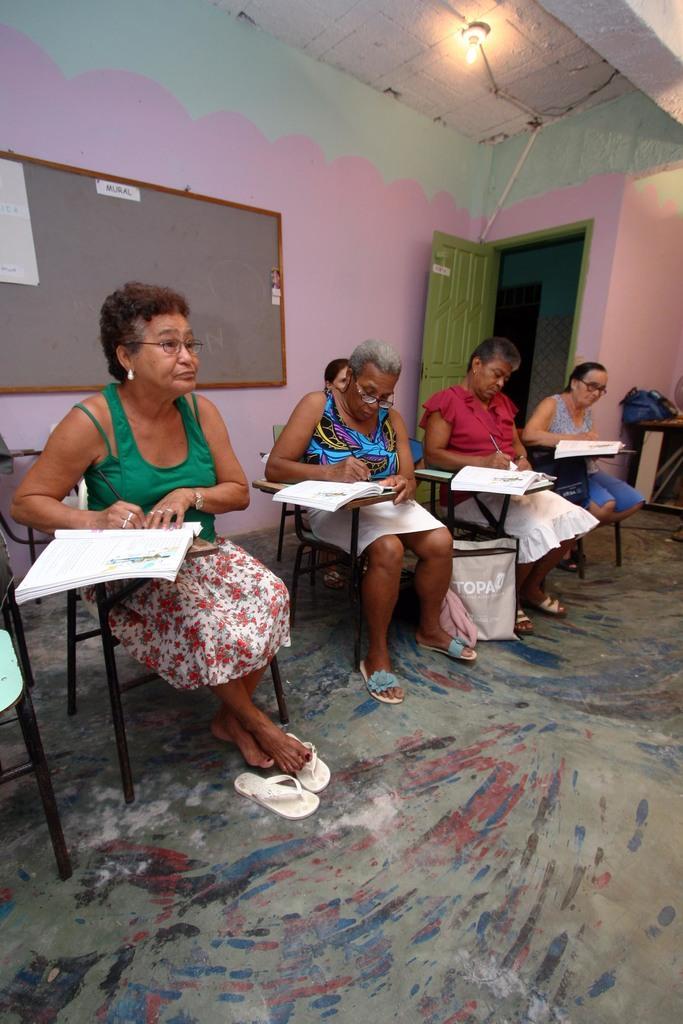In one or two sentences, can you explain what this image depicts? It is a classroom there are few women sitting and holding books, there is a bag beside the second woman, in the background there is a notice board, to the right side there is a door behind the door there is a pink and green color wall. 